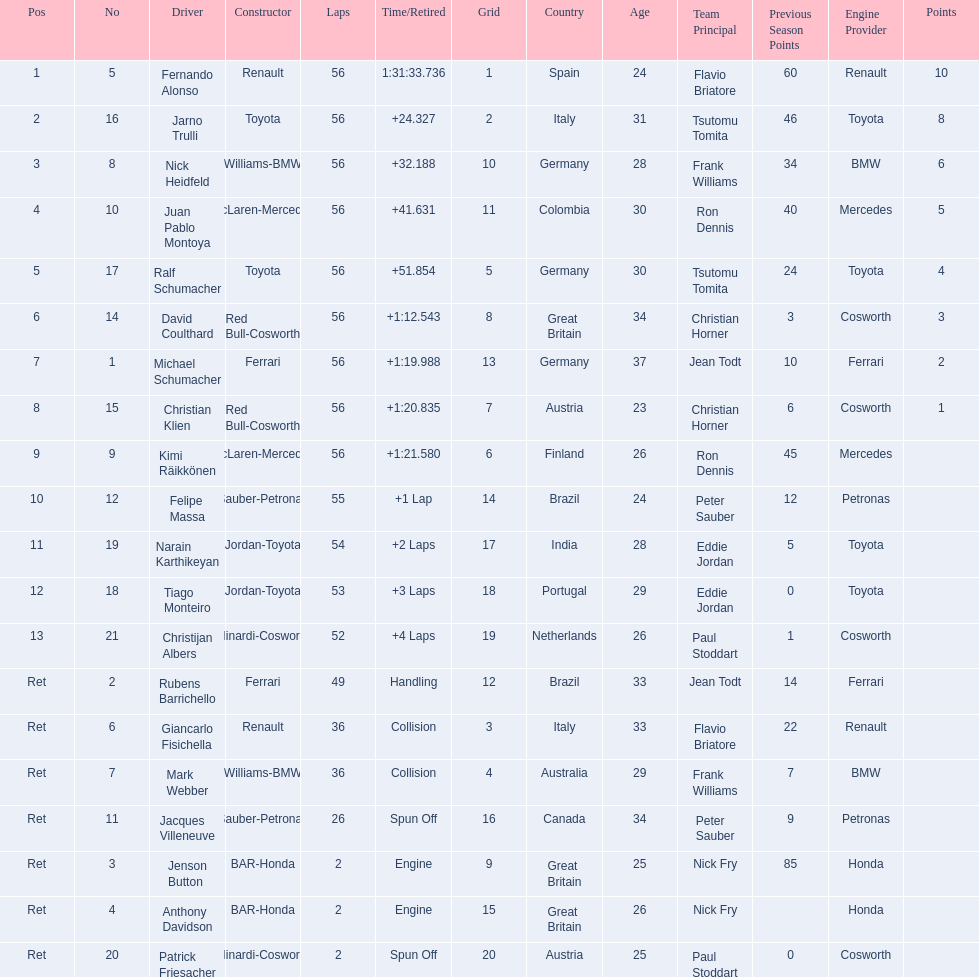How many bmw vehicles completed the race ahead of webber? 1. 